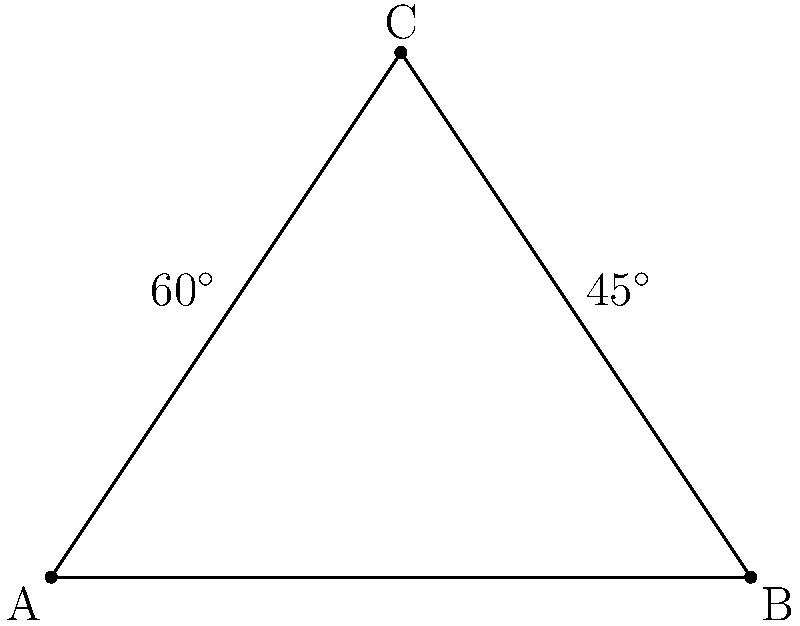In a football formation, three players form a triangle on the field. The angle between two players at the base is 60°, and the angle between one base player and the player at the apex is 45°. What is the measure of the remaining angle in the triangle? Let's approach this step-by-step:

1) In any triangle, the sum of all interior angles is always 180°. This is a fundamental property of triangles.

2) We are given two angles in the triangle:
   - One angle is 60°
   - Another angle is 45°

3) Let's call the unknown angle $x$.

4) We can set up an equation based on the fact that all angles must sum to 180°:

   $60^\circ + 45^\circ + x = 180^\circ$

5) Simplifying the left side of the equation:

   $105^\circ + x = 180^\circ$

6) To solve for $x$, we subtract 105° from both sides:

   $x = 180^\circ - 105^\circ = 75^\circ$

Therefore, the measure of the remaining angle in the triangle is 75°.
Answer: 75° 